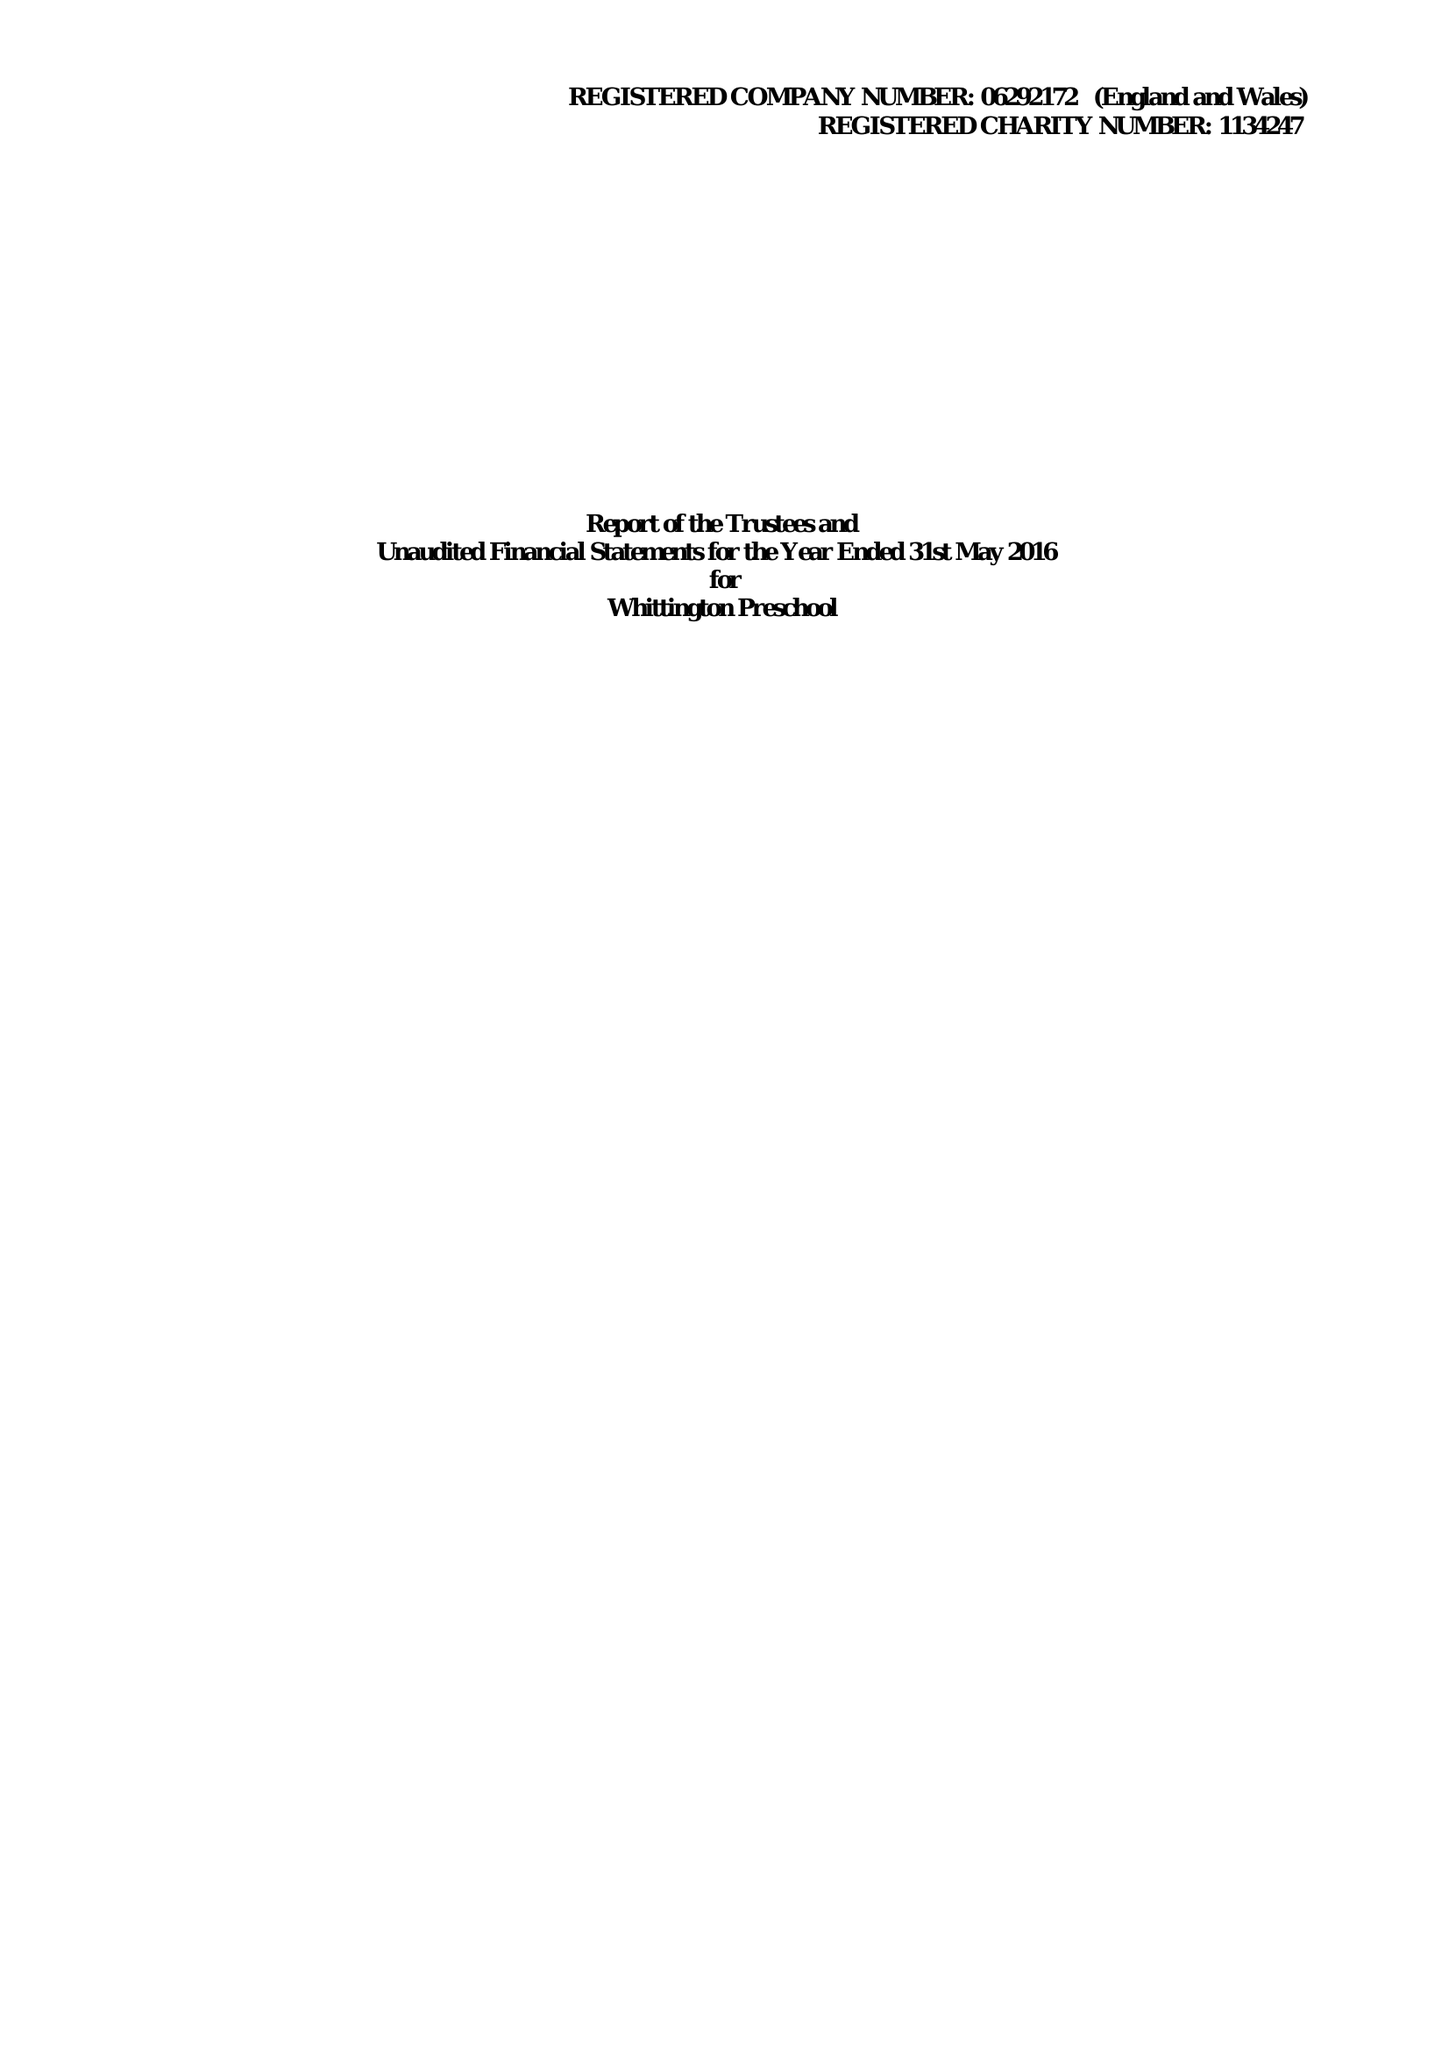What is the value for the address__postcode?
Answer the question using a single word or phrase. WS14 9PY 